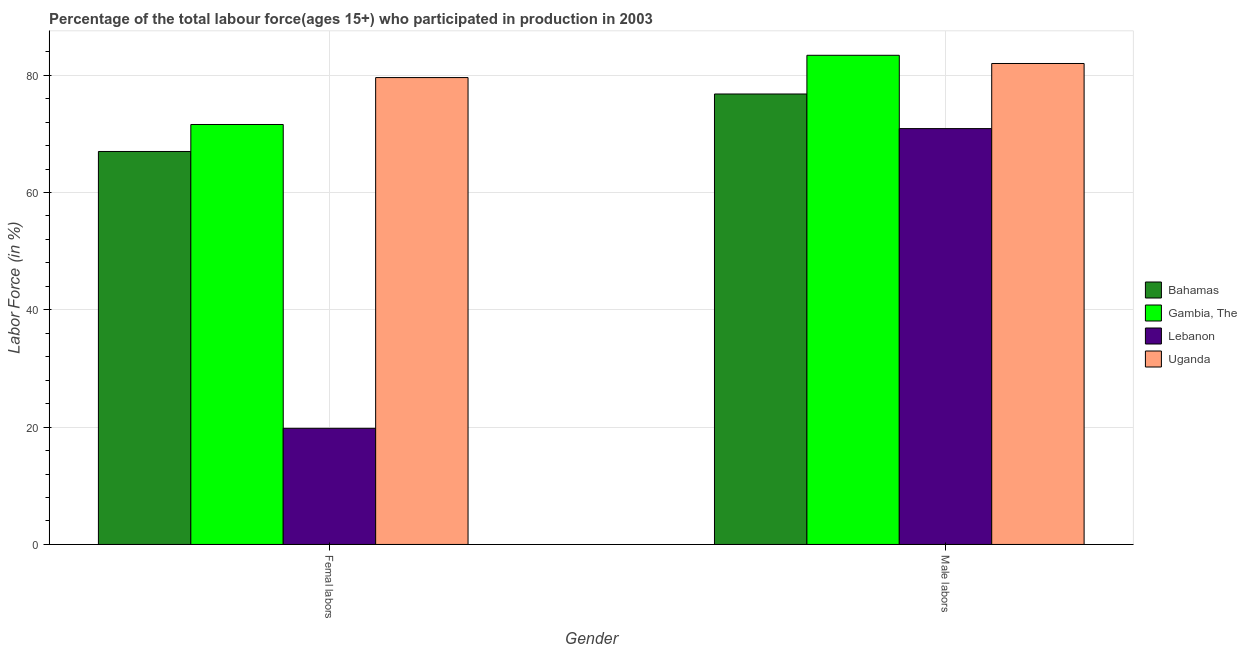How many different coloured bars are there?
Provide a short and direct response. 4. How many bars are there on the 2nd tick from the right?
Ensure brevity in your answer.  4. What is the label of the 1st group of bars from the left?
Provide a succinct answer. Femal labors. What is the percentage of female labor force in Gambia, The?
Make the answer very short. 71.6. Across all countries, what is the maximum percentage of male labour force?
Your answer should be compact. 83.4. Across all countries, what is the minimum percentage of male labour force?
Provide a short and direct response. 70.9. In which country was the percentage of male labour force maximum?
Give a very brief answer. Gambia, The. In which country was the percentage of male labour force minimum?
Your response must be concise. Lebanon. What is the total percentage of female labor force in the graph?
Provide a succinct answer. 238. What is the difference between the percentage of male labour force in Uganda and that in Lebanon?
Offer a very short reply. 11.1. What is the difference between the percentage of male labour force in Lebanon and the percentage of female labor force in Gambia, The?
Make the answer very short. -0.7. What is the average percentage of male labour force per country?
Offer a very short reply. 78.28. What is the difference between the percentage of female labor force and percentage of male labour force in Bahamas?
Your answer should be compact. -9.8. In how many countries, is the percentage of male labour force greater than 48 %?
Keep it short and to the point. 4. What is the ratio of the percentage of male labour force in Uganda to that in Lebanon?
Your answer should be very brief. 1.16. Is the percentage of male labour force in Gambia, The less than that in Uganda?
Offer a very short reply. No. In how many countries, is the percentage of female labor force greater than the average percentage of female labor force taken over all countries?
Make the answer very short. 3. What does the 1st bar from the left in Femal labors represents?
Your response must be concise. Bahamas. What does the 2nd bar from the right in Male labors represents?
Offer a very short reply. Lebanon. How many bars are there?
Offer a very short reply. 8. What is the difference between two consecutive major ticks on the Y-axis?
Offer a terse response. 20. Are the values on the major ticks of Y-axis written in scientific E-notation?
Make the answer very short. No. How are the legend labels stacked?
Ensure brevity in your answer.  Vertical. What is the title of the graph?
Provide a short and direct response. Percentage of the total labour force(ages 15+) who participated in production in 2003. Does "Heavily indebted poor countries" appear as one of the legend labels in the graph?
Offer a very short reply. No. What is the Labor Force (in %) in Bahamas in Femal labors?
Your answer should be very brief. 67. What is the Labor Force (in %) in Gambia, The in Femal labors?
Keep it short and to the point. 71.6. What is the Labor Force (in %) in Lebanon in Femal labors?
Your answer should be compact. 19.8. What is the Labor Force (in %) in Uganda in Femal labors?
Keep it short and to the point. 79.6. What is the Labor Force (in %) in Bahamas in Male labors?
Keep it short and to the point. 76.8. What is the Labor Force (in %) in Gambia, The in Male labors?
Keep it short and to the point. 83.4. What is the Labor Force (in %) in Lebanon in Male labors?
Provide a short and direct response. 70.9. Across all Gender, what is the maximum Labor Force (in %) in Bahamas?
Provide a short and direct response. 76.8. Across all Gender, what is the maximum Labor Force (in %) of Gambia, The?
Make the answer very short. 83.4. Across all Gender, what is the maximum Labor Force (in %) in Lebanon?
Offer a very short reply. 70.9. Across all Gender, what is the maximum Labor Force (in %) in Uganda?
Provide a short and direct response. 82. Across all Gender, what is the minimum Labor Force (in %) of Gambia, The?
Your response must be concise. 71.6. Across all Gender, what is the minimum Labor Force (in %) of Lebanon?
Ensure brevity in your answer.  19.8. Across all Gender, what is the minimum Labor Force (in %) in Uganda?
Provide a short and direct response. 79.6. What is the total Labor Force (in %) in Bahamas in the graph?
Give a very brief answer. 143.8. What is the total Labor Force (in %) in Gambia, The in the graph?
Provide a short and direct response. 155. What is the total Labor Force (in %) of Lebanon in the graph?
Your answer should be very brief. 90.7. What is the total Labor Force (in %) in Uganda in the graph?
Provide a short and direct response. 161.6. What is the difference between the Labor Force (in %) of Bahamas in Femal labors and that in Male labors?
Provide a short and direct response. -9.8. What is the difference between the Labor Force (in %) in Lebanon in Femal labors and that in Male labors?
Offer a very short reply. -51.1. What is the difference between the Labor Force (in %) in Uganda in Femal labors and that in Male labors?
Give a very brief answer. -2.4. What is the difference between the Labor Force (in %) in Bahamas in Femal labors and the Labor Force (in %) in Gambia, The in Male labors?
Provide a succinct answer. -16.4. What is the difference between the Labor Force (in %) of Bahamas in Femal labors and the Labor Force (in %) of Lebanon in Male labors?
Offer a very short reply. -3.9. What is the difference between the Labor Force (in %) in Bahamas in Femal labors and the Labor Force (in %) in Uganda in Male labors?
Provide a succinct answer. -15. What is the difference between the Labor Force (in %) in Gambia, The in Femal labors and the Labor Force (in %) in Lebanon in Male labors?
Offer a terse response. 0.7. What is the difference between the Labor Force (in %) in Lebanon in Femal labors and the Labor Force (in %) in Uganda in Male labors?
Give a very brief answer. -62.2. What is the average Labor Force (in %) in Bahamas per Gender?
Offer a very short reply. 71.9. What is the average Labor Force (in %) of Gambia, The per Gender?
Ensure brevity in your answer.  77.5. What is the average Labor Force (in %) of Lebanon per Gender?
Your response must be concise. 45.35. What is the average Labor Force (in %) of Uganda per Gender?
Keep it short and to the point. 80.8. What is the difference between the Labor Force (in %) in Bahamas and Labor Force (in %) in Lebanon in Femal labors?
Keep it short and to the point. 47.2. What is the difference between the Labor Force (in %) of Gambia, The and Labor Force (in %) of Lebanon in Femal labors?
Your response must be concise. 51.8. What is the difference between the Labor Force (in %) of Lebanon and Labor Force (in %) of Uganda in Femal labors?
Your response must be concise. -59.8. What is the difference between the Labor Force (in %) in Bahamas and Labor Force (in %) in Uganda in Male labors?
Your response must be concise. -5.2. What is the difference between the Labor Force (in %) in Lebanon and Labor Force (in %) in Uganda in Male labors?
Offer a very short reply. -11.1. What is the ratio of the Labor Force (in %) of Bahamas in Femal labors to that in Male labors?
Your answer should be compact. 0.87. What is the ratio of the Labor Force (in %) in Gambia, The in Femal labors to that in Male labors?
Give a very brief answer. 0.86. What is the ratio of the Labor Force (in %) of Lebanon in Femal labors to that in Male labors?
Provide a short and direct response. 0.28. What is the ratio of the Labor Force (in %) in Uganda in Femal labors to that in Male labors?
Provide a succinct answer. 0.97. What is the difference between the highest and the second highest Labor Force (in %) of Gambia, The?
Your answer should be compact. 11.8. What is the difference between the highest and the second highest Labor Force (in %) in Lebanon?
Give a very brief answer. 51.1. What is the difference between the highest and the second highest Labor Force (in %) in Uganda?
Offer a terse response. 2.4. What is the difference between the highest and the lowest Labor Force (in %) in Lebanon?
Your answer should be very brief. 51.1. 